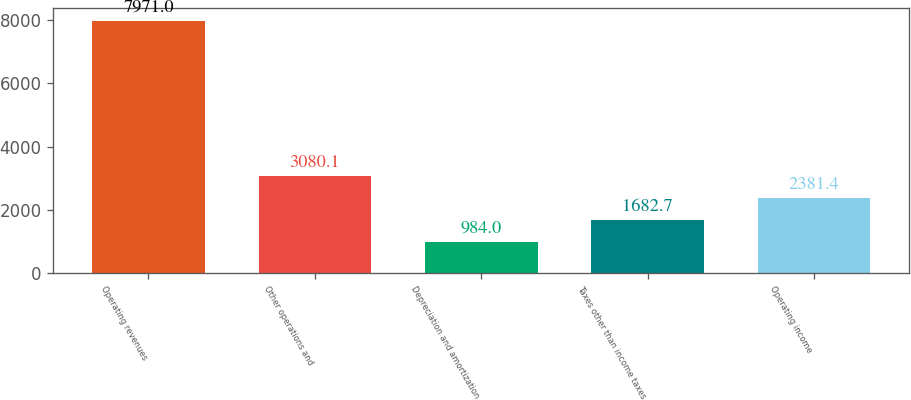Convert chart to OTSL. <chart><loc_0><loc_0><loc_500><loc_500><bar_chart><fcel>Operating revenues<fcel>Other operations and<fcel>Depreciation and amortization<fcel>Taxes other than income taxes<fcel>Operating income<nl><fcel>7971<fcel>3080.1<fcel>984<fcel>1682.7<fcel>2381.4<nl></chart> 